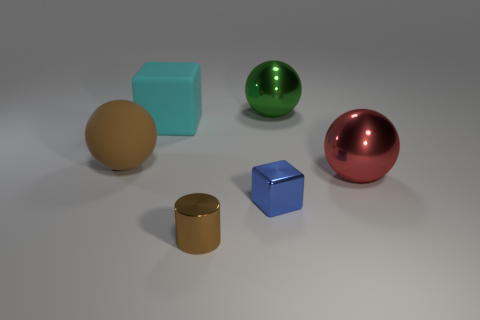Are there any other tiny blocks made of the same material as the cyan block?
Offer a terse response. No. The cube in front of the sphere that is on the left side of the blue thing is made of what material?
Your answer should be compact. Metal. What number of other shiny objects have the same shape as the large red metallic thing?
Ensure brevity in your answer.  1. What shape is the cyan object?
Ensure brevity in your answer.  Cube. Are there fewer small blue blocks than small yellow metallic cubes?
Provide a succinct answer. No. Are there any other things that are the same size as the green thing?
Provide a succinct answer. Yes. There is another thing that is the same shape as the cyan rubber thing; what material is it?
Offer a terse response. Metal. Are there more big matte objects than metallic cylinders?
Keep it short and to the point. Yes. How many other things are the same color as the tiny shiny cube?
Provide a short and direct response. 0. Is the big cyan block made of the same material as the brown thing in front of the big red ball?
Ensure brevity in your answer.  No. 